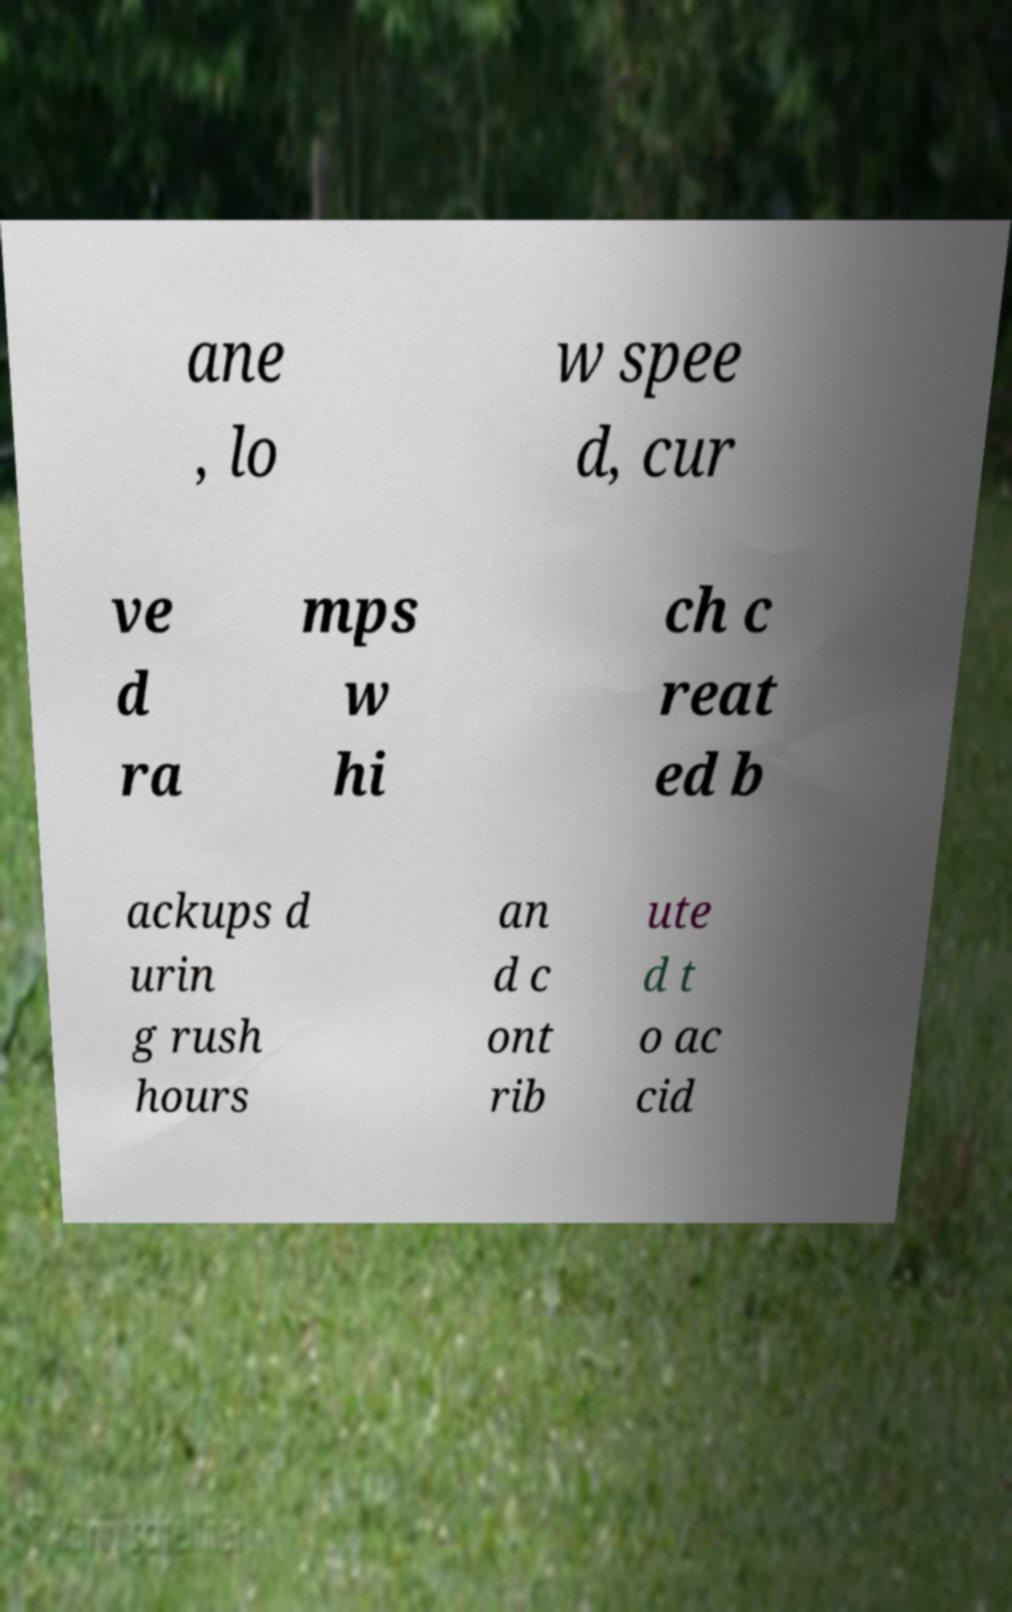Can you accurately transcribe the text from the provided image for me? ane , lo w spee d, cur ve d ra mps w hi ch c reat ed b ackups d urin g rush hours an d c ont rib ute d t o ac cid 